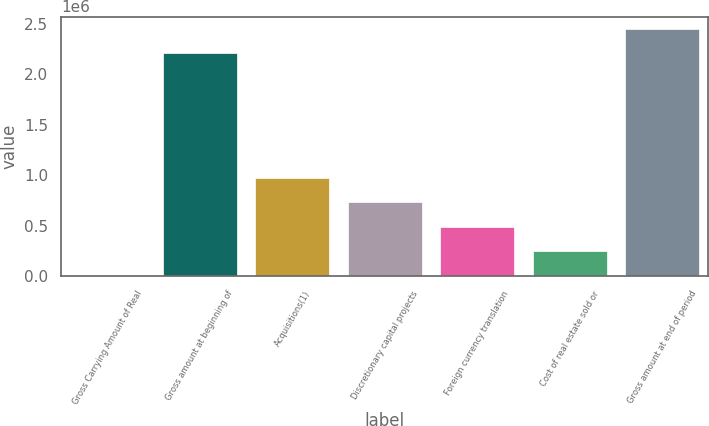Convert chart. <chart><loc_0><loc_0><loc_500><loc_500><bar_chart><fcel>Gross Carrying Amount of Real<fcel>Gross amount at beginning of<fcel>Acquisitions(1)<fcel>Discretionary capital projects<fcel>Foreign currency translation<fcel>Cost of real estate sold or<fcel>Gross amount at end of period<nl><fcel>2016<fcel>2.20499e+06<fcel>972226<fcel>729673<fcel>487121<fcel>244568<fcel>2.44754e+06<nl></chart> 